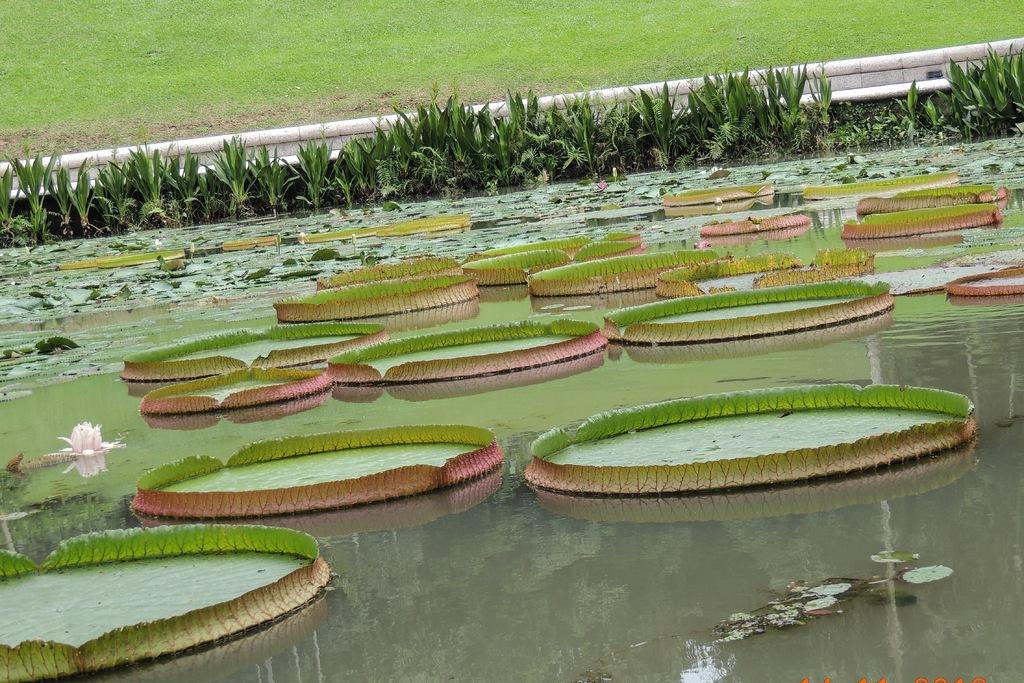What type of vegetation can be seen in the image? There is green grass and plants visible in the image. What is the water feature in the image? There is water in the image. What specific type of plant is present in the image? Lotus flowers are present in the image. What part of the lotus plant can be seen in the image? Lotus leaves are visible in the image. What type of pets can be seen playing in the water in the image? There are no pets visible in the image; it features lotus flowers and leaves in water. 